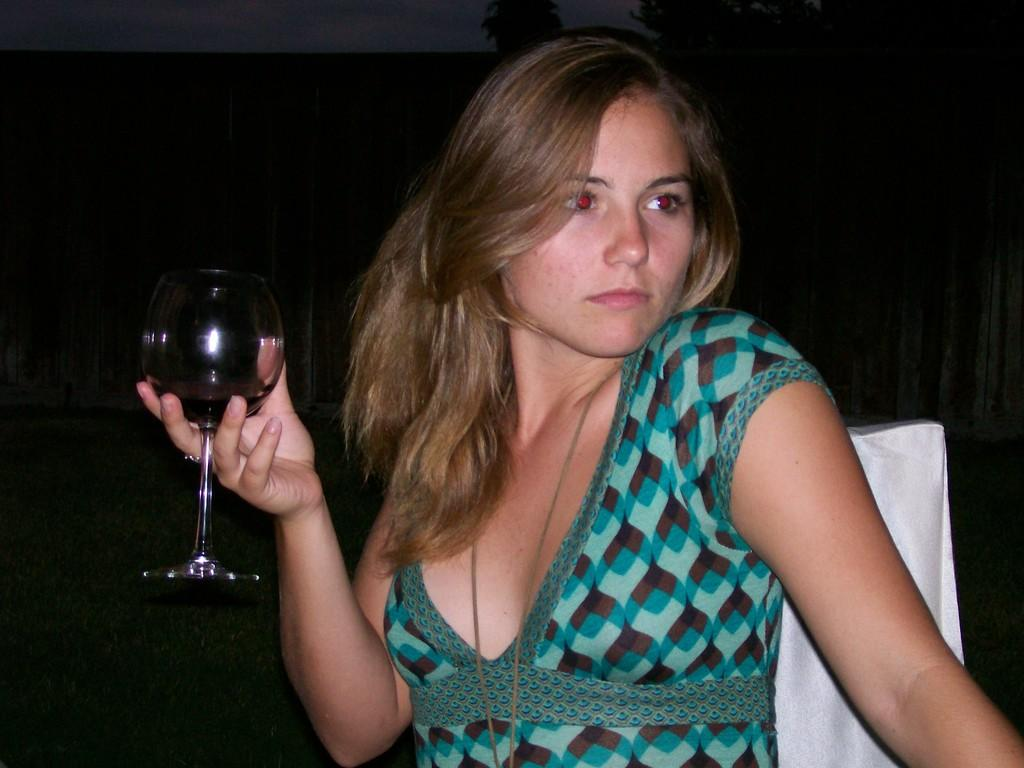Who is present in the image? There is a woman in the image. What is the woman wearing? The woman is wearing a green dress. What is the woman holding in the image? The woman is holding a glass. Can you describe the background of the image? The background of the image is dark. What can be seen on the right side of the image? There is a chair on the right side of the image. What type of harmony can be heard in the background of the image? There is no audible harmony in the image, as it is a still photograph. 